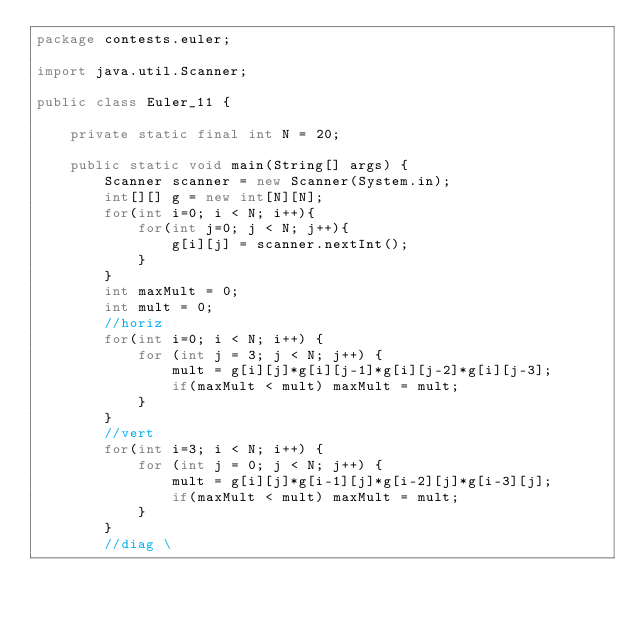Convert code to text. <code><loc_0><loc_0><loc_500><loc_500><_Java_>package contests.euler;

import java.util.Scanner;

public class Euler_11 {

    private static final int N = 20;

    public static void main(String[] args) {
        Scanner scanner = new Scanner(System.in);
        int[][] g = new int[N][N];
        for(int i=0; i < N; i++){
            for(int j=0; j < N; j++){
                g[i][j] = scanner.nextInt();
            }
        }
        int maxMult = 0;
        int mult = 0;
        //horiz
        for(int i=0; i < N; i++) {
            for (int j = 3; j < N; j++) {
                mult = g[i][j]*g[i][j-1]*g[i][j-2]*g[i][j-3];
                if(maxMult < mult) maxMult = mult;
            }
        }
        //vert
        for(int i=3; i < N; i++) {
            for (int j = 0; j < N; j++) {
                mult = g[i][j]*g[i-1][j]*g[i-2][j]*g[i-3][j];
                if(maxMult < mult) maxMult = mult;
            }
        }
        //diag \</code> 